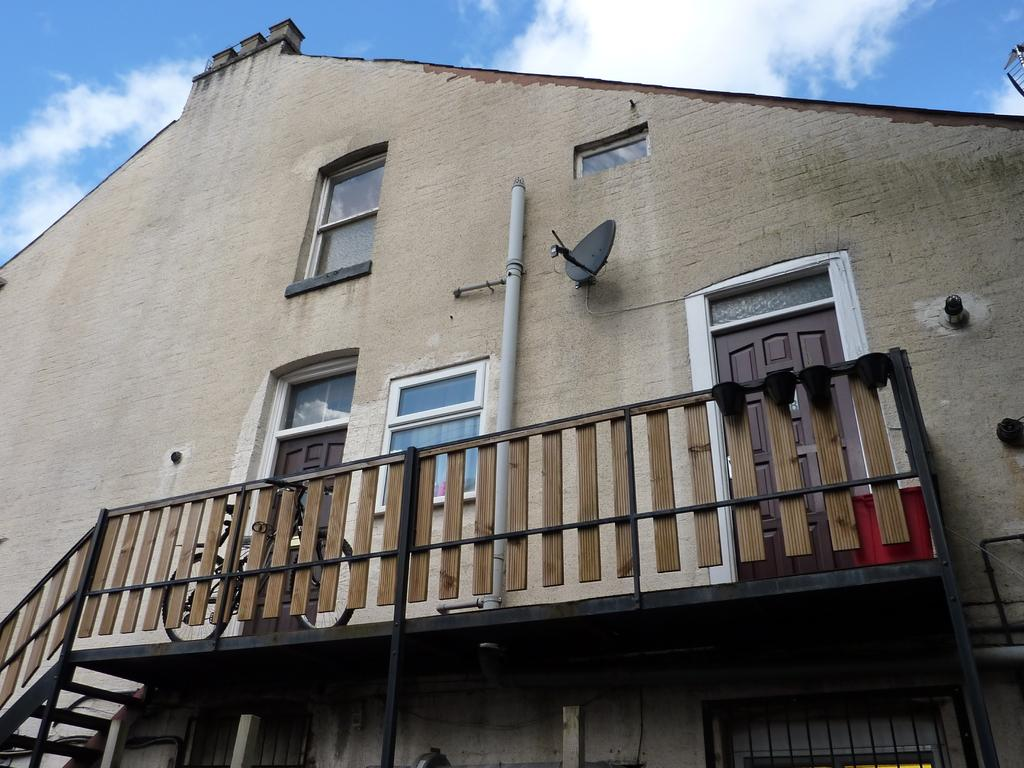What structures are present in the image? There are buildings in the image. What features can be observed on the buildings? The buildings have windows and railing. What is visible in the background of the image? The sky is visible in the image. What type of acoustics can be heard coming from the buildings in the image? There is no information about the acoustics or any sounds in the image, so it's not possible to determine what might be heard. How many sisters are visible in the image? There is no reference to any sisters in the image, so it's not possible to determine if any are present. 